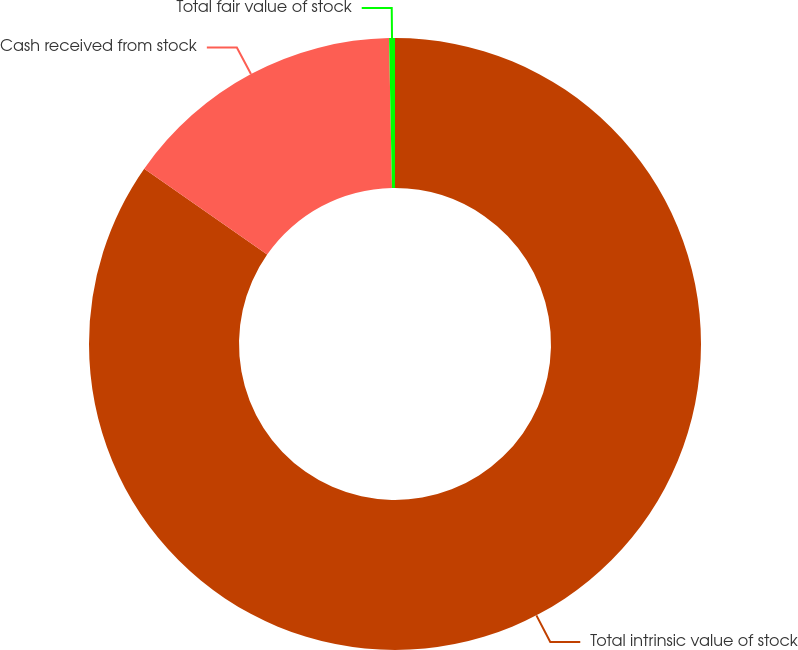<chart> <loc_0><loc_0><loc_500><loc_500><pie_chart><fcel>Total intrinsic value of stock<fcel>Cash received from stock<fcel>Total fair value of stock<nl><fcel>84.71%<fcel>14.98%<fcel>0.31%<nl></chart> 